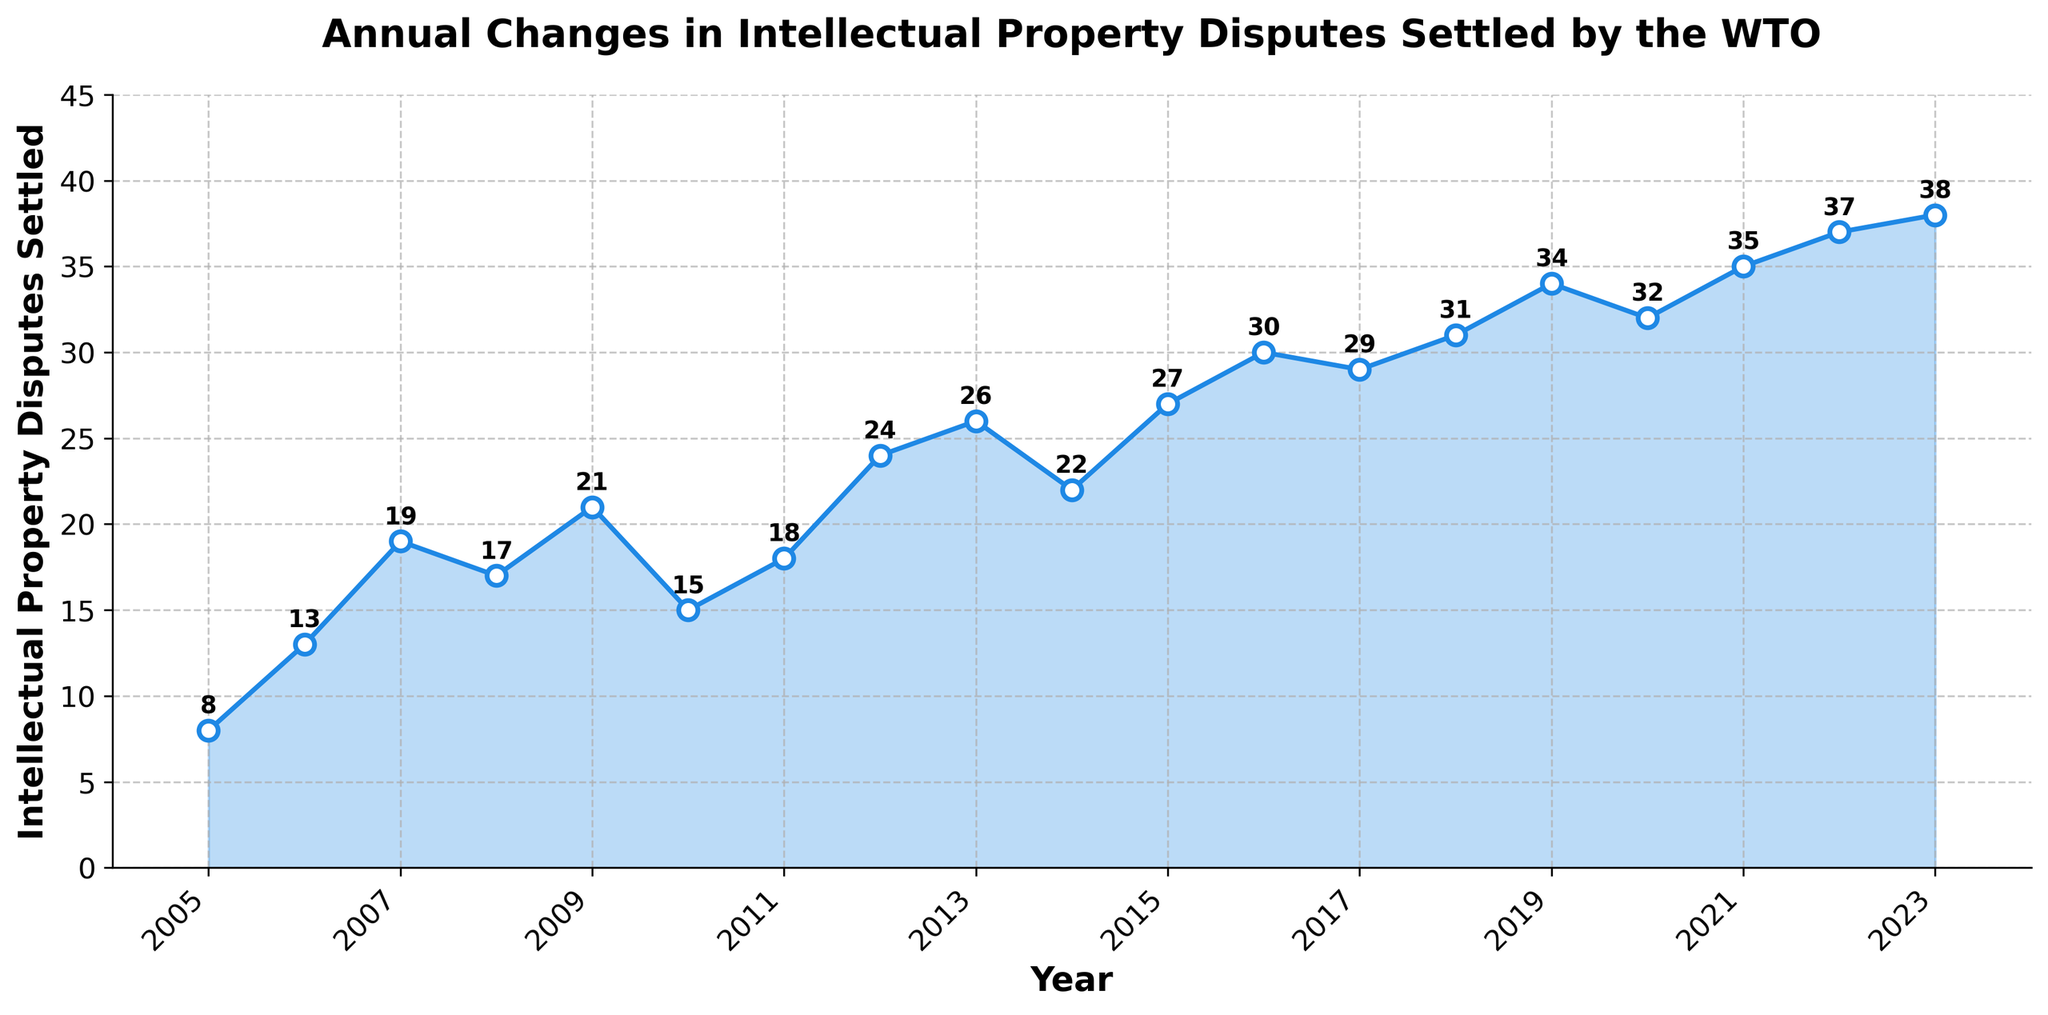How many Intellectual Property Disputes were settled in 2013? The figure shows the disputes settled each year. In 2013, the number of disputes settled is annotated directly above the data point.
Answer: 26 What is the trend in the number of disputes settled between 2010 and 2015? Referring to the years 2010 to 2015, you can observe the plotted line and annotations above each data point. The disputes increase from 15 in 2010 to 27 in 2015.
Answer: Increasing Which year had the highest number of disputes settled? Look at the data points where the number is the highest and check the annotations. The highest value is 38 in 2023.
Answer: 2023 How did the number of disputes settled change from 2008 to 2009? Compare the numbers annotated above the data points for 2008 and 2009. It increased from 17 in 2008 to 21 in 2009.
Answer: Increased What is the average number of Intellectual Property Disputes settled from 2018 to 2023? Add the number of disputes from 2018 to 2023 (31 + 34 + 32 + 35 + 37 + 38) and divide by the number of years, which is 6. The sum is 207, so the average is 207/6 = 34.5
Answer: 34.5 Which year witnessed the second-lowest number of disputes settled, and how many were settled that year? First, find the lowest number, then find the next lowest from the annotated points. The lowest is 8 in 2005, and the second-lowest is 13 in 2006.
Answer: 2006, 13 What was the difference in Intellectual Property Disputes settled between 2006 and 2007? Subtract the number of disputes in 2006 from those in 2007 (19 - 13).
Answer: 6 What was the average growth in the number of disputes settled per year over the entire period? Calculate the difference between 2023 and 2005 number of disputes (38 - 8), and divide by the number of years (2023 - 2005 + 1 = 19). The total growth is 30, so the average growth per year is 30/19 ≈ 1.58.
Answer: 1.58 In which year did the number of disputes settled first exceed 30? Observe the figures and identify the year where the number first exceeds 30 by looking at the annotations above the data points. This occurs in 2016.
Answer: 2016 